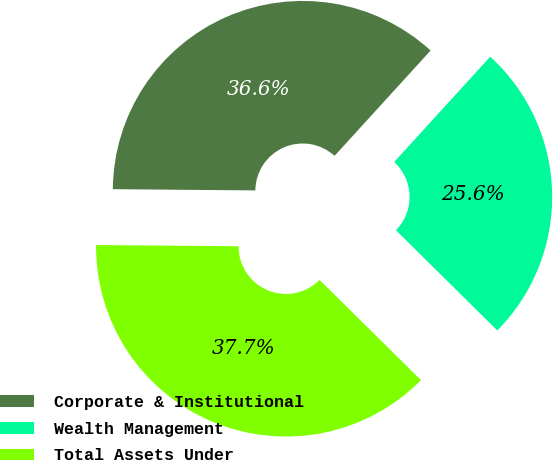Convert chart to OTSL. <chart><loc_0><loc_0><loc_500><loc_500><pie_chart><fcel>Corporate & Institutional<fcel>Wealth Management<fcel>Total Assets Under<nl><fcel>36.63%<fcel>25.64%<fcel>37.73%<nl></chart> 